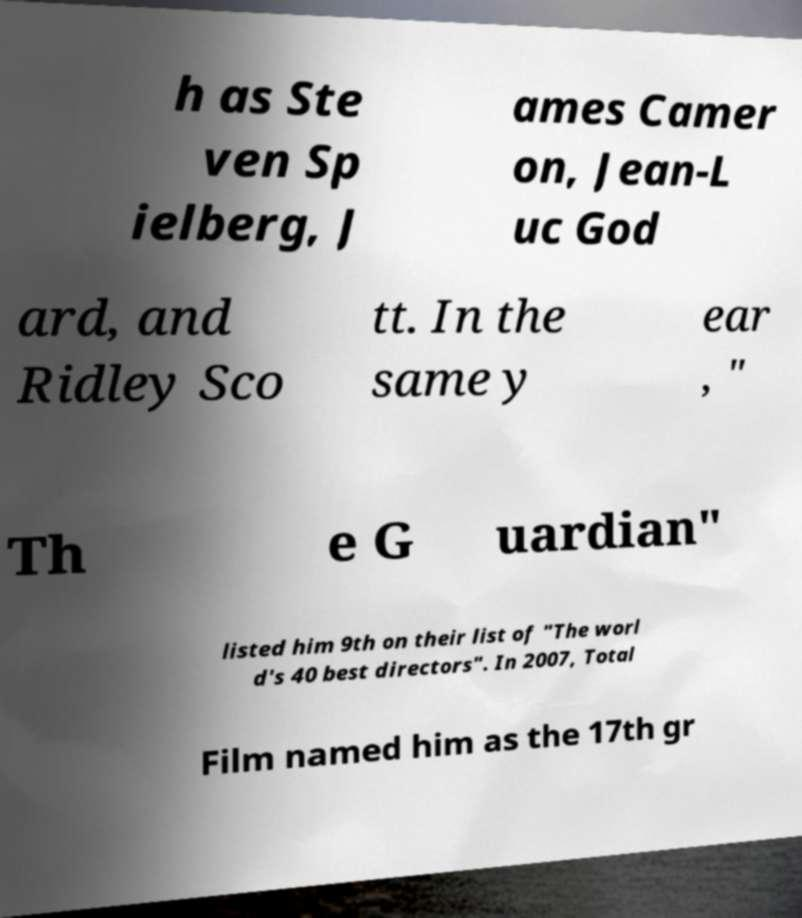Please identify and transcribe the text found in this image. h as Ste ven Sp ielberg, J ames Camer on, Jean-L uc God ard, and Ridley Sco tt. In the same y ear , " Th e G uardian" listed him 9th on their list of "The worl d's 40 best directors". In 2007, Total Film named him as the 17th gr 